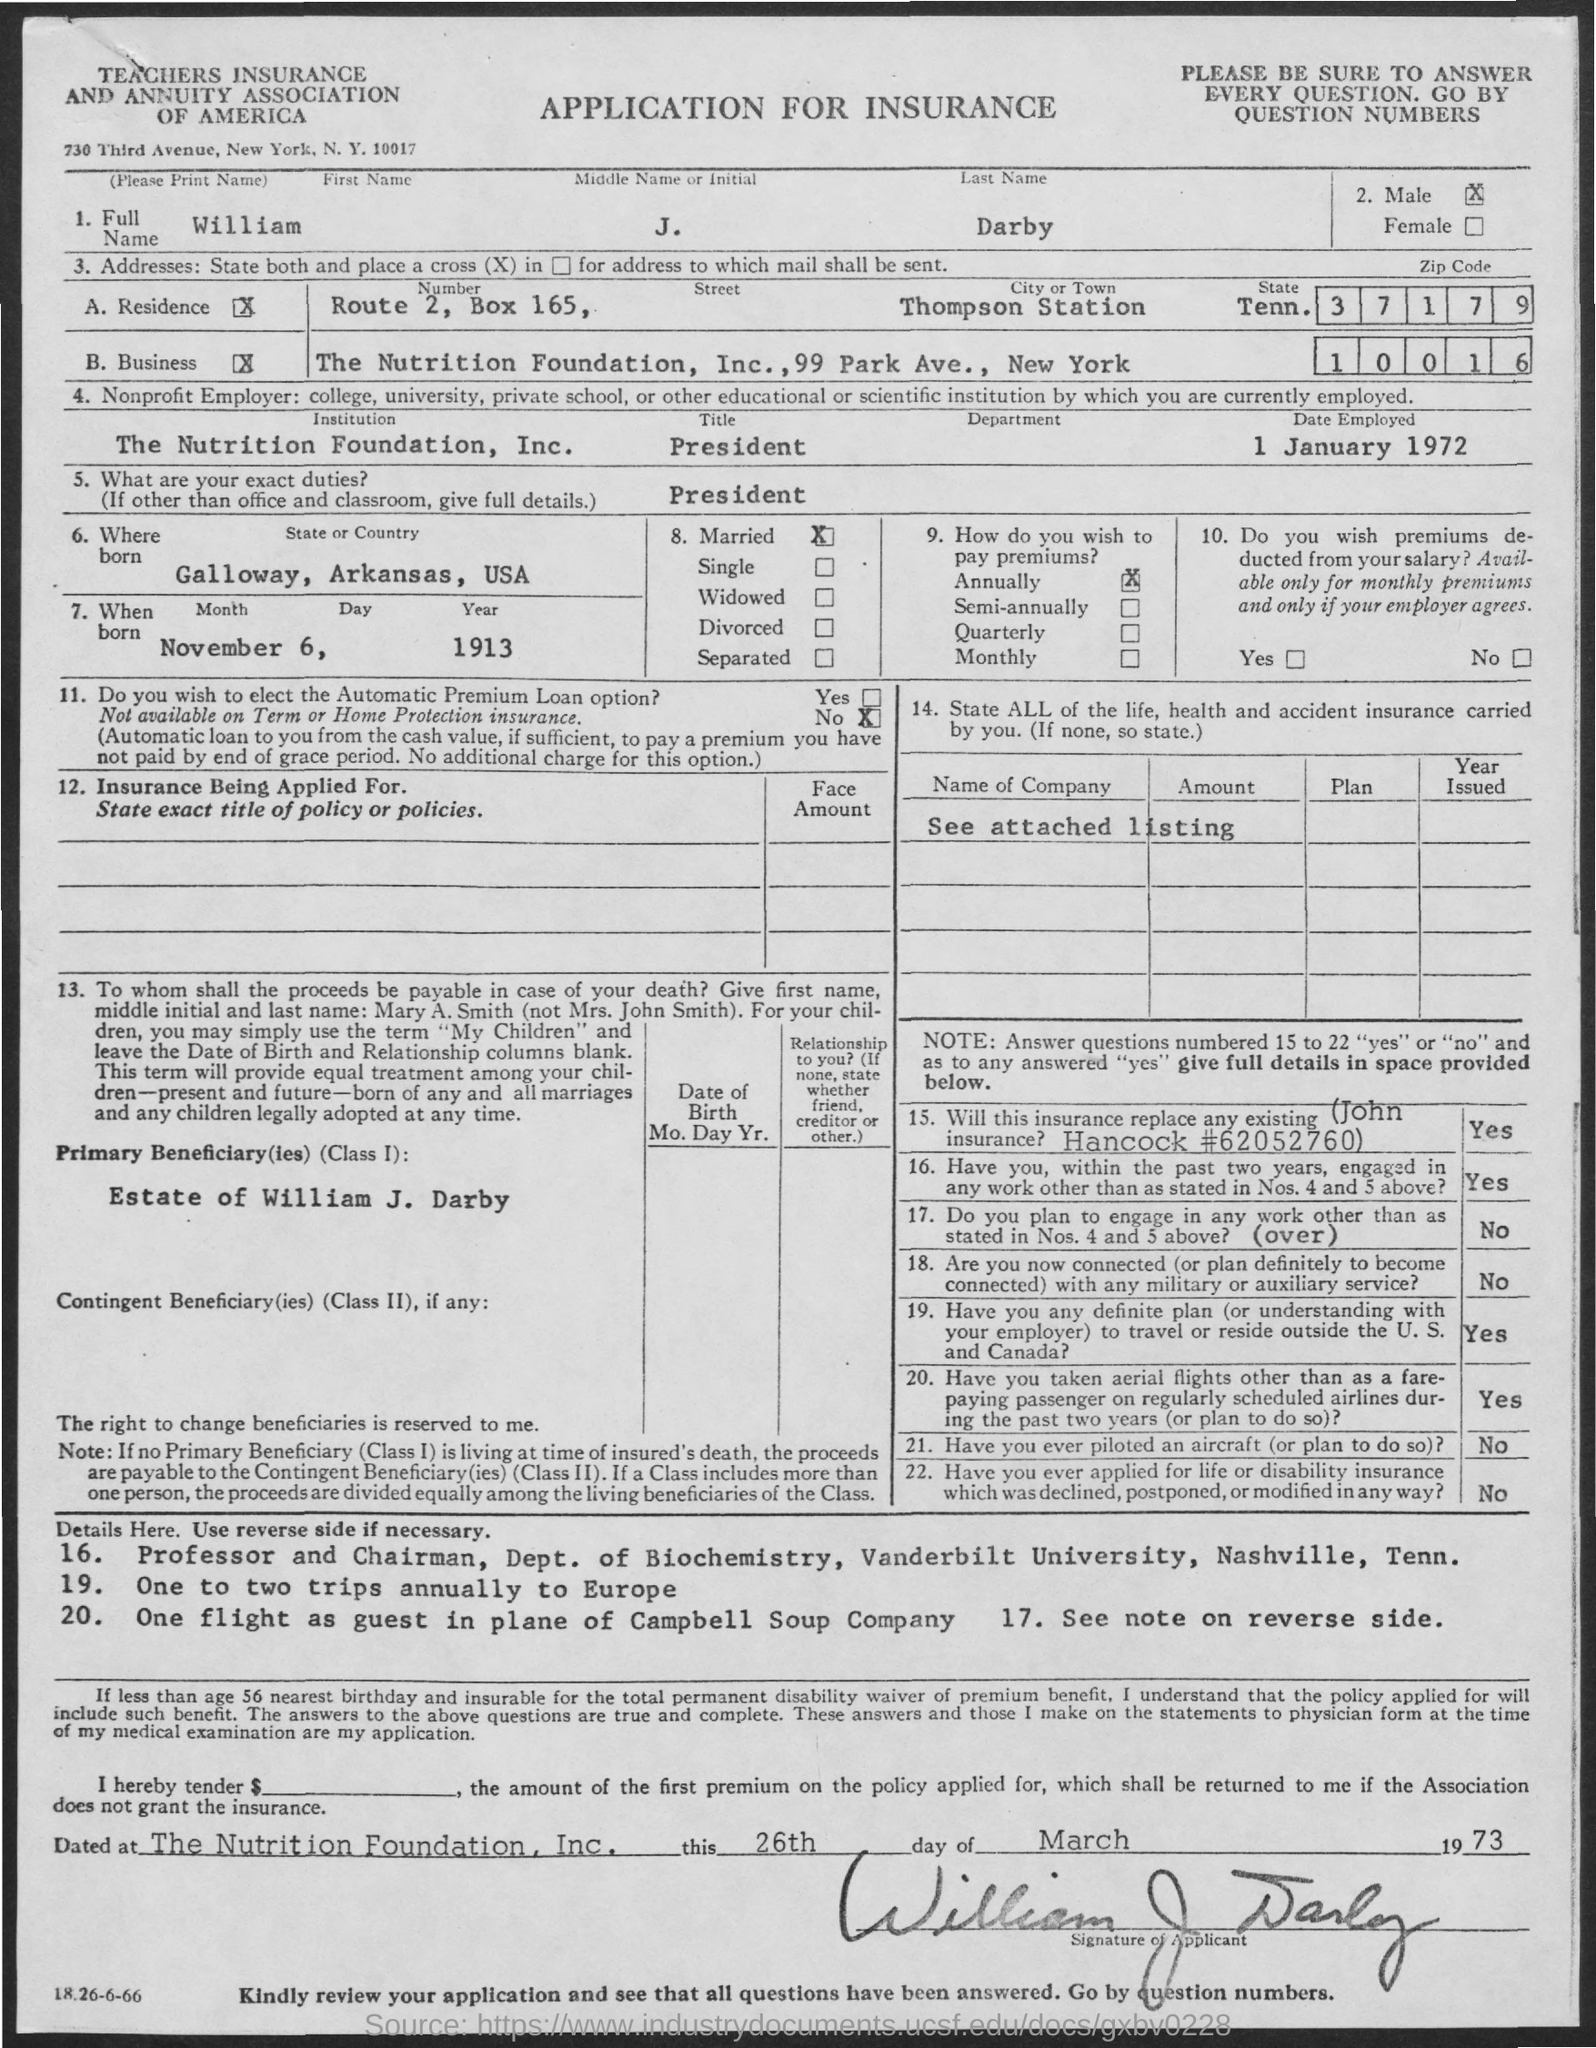List a handful of essential elements in this visual. William J. Darby wishes to pay the premium annually. November 6, 1913, was the date of his birth. The date of employment is January 1, 1972. The city or town of Thompson Station has been identified as a location for the construction of a new plant. The person was born in the state or country of Galloway, Arkansas, USA. 